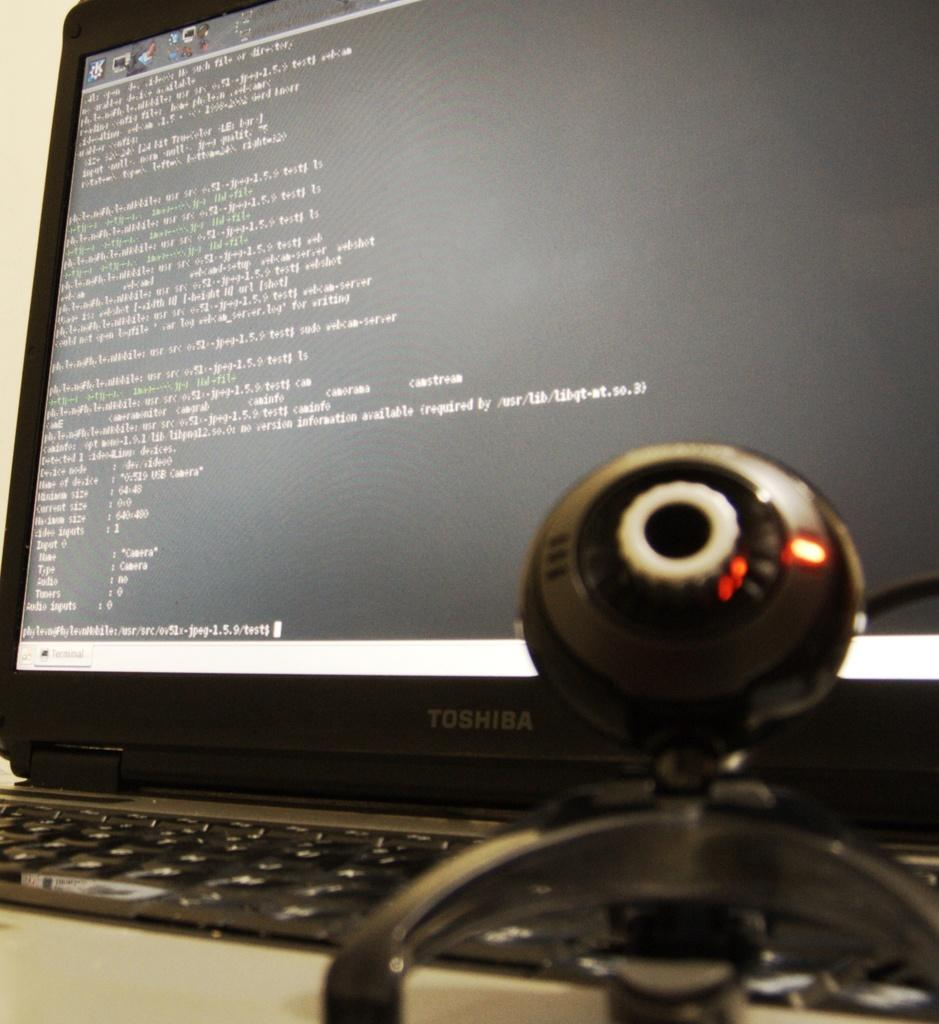<image>
Share a concise interpretation of the image provided. Webcam in front of a laptop that is made by TOSHIBA. 